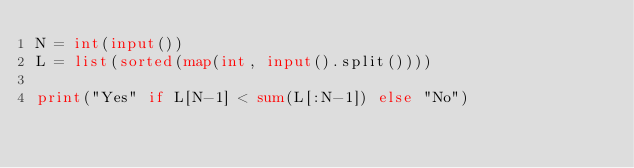<code> <loc_0><loc_0><loc_500><loc_500><_Python_>N = int(input())
L = list(sorted(map(int, input().split())))

print("Yes" if L[N-1] < sum(L[:N-1]) else "No")</code> 